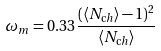<formula> <loc_0><loc_0><loc_500><loc_500>\omega _ { m } = 0 . 3 3 \frac { ( \langle N _ { \mathrm c h } \rangle - 1 ) ^ { 2 } } { \langle N _ { \mathrm c h } \rangle }</formula> 